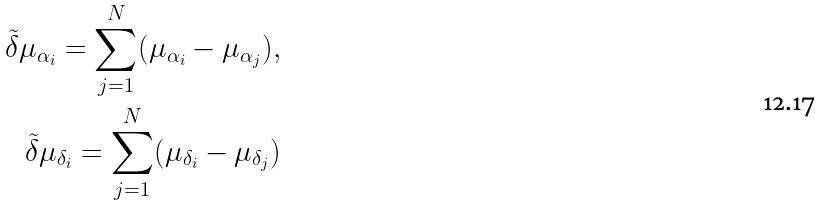Convert formula to latex. <formula><loc_0><loc_0><loc_500><loc_500>\tilde { \delta } \mu _ { \alpha _ { i } } = \sum _ { j = 1 } ^ { N } ( \mu _ { \alpha _ { i } } - \mu _ { \alpha _ { j } } ) , \\ \tilde { \delta } \mu _ { \delta _ { i } } = \sum _ { j = 1 } ^ { N } ( \mu _ { \delta _ { i } } - \mu _ { \delta _ { j } } )</formula> 